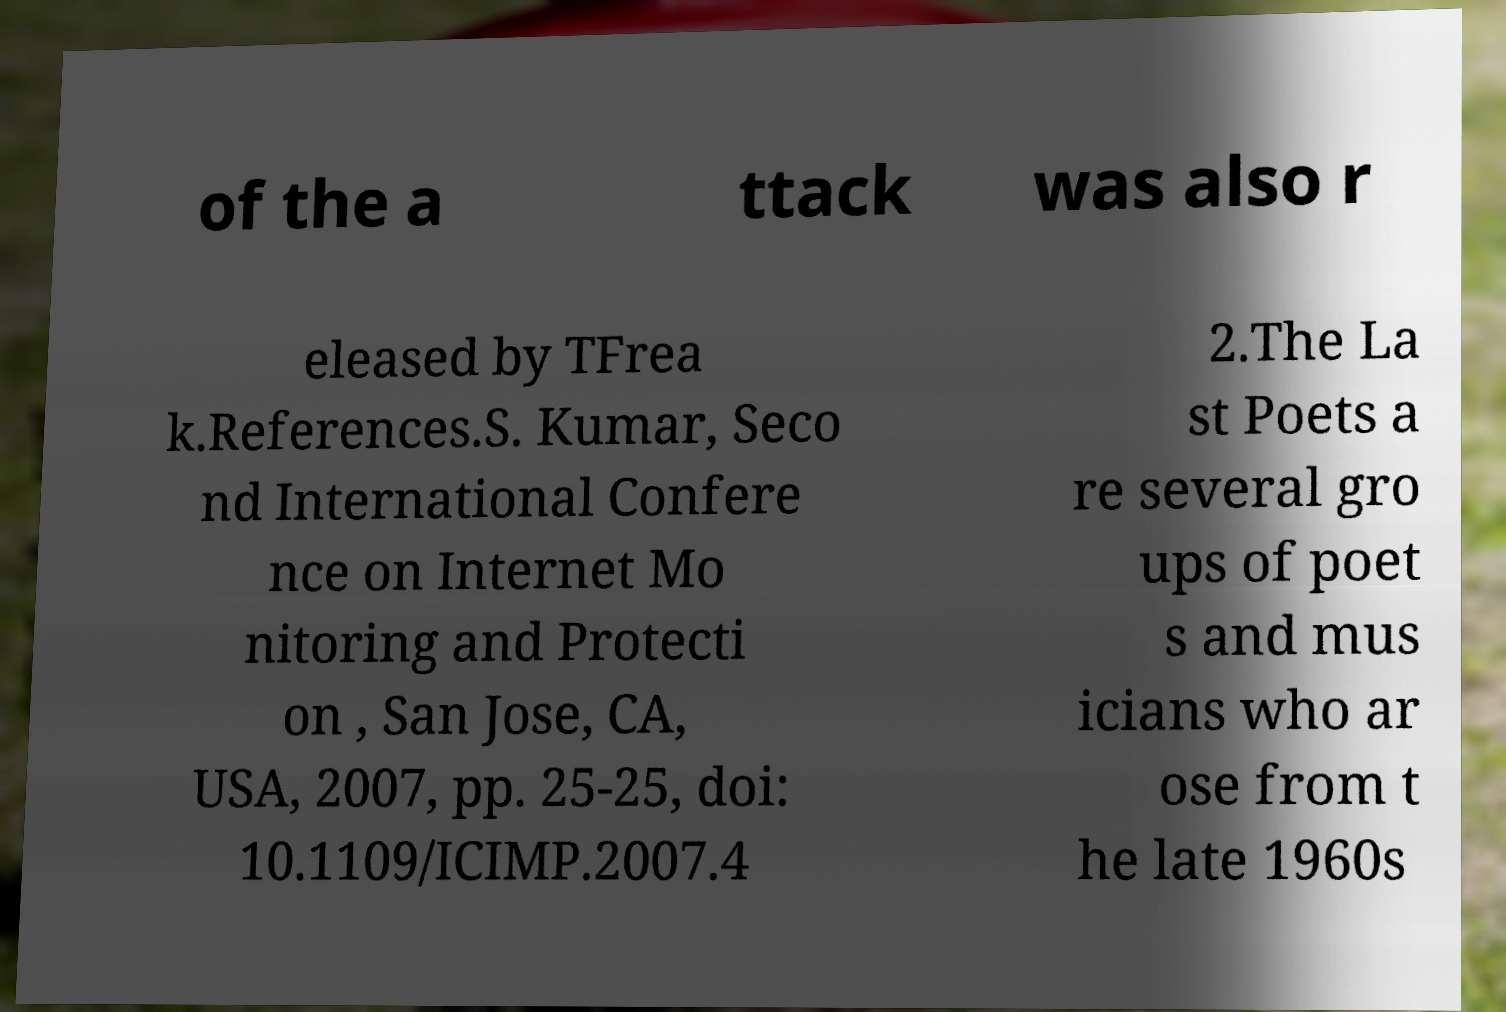Could you extract and type out the text from this image? of the a ttack was also r eleased by TFrea k.References.S. Kumar, Seco nd International Confere nce on Internet Mo nitoring and Protecti on , San Jose, CA, USA, 2007, pp. 25-25, doi: 10.1109/ICIMP.2007.4 2.The La st Poets a re several gro ups of poet s and mus icians who ar ose from t he late 1960s 